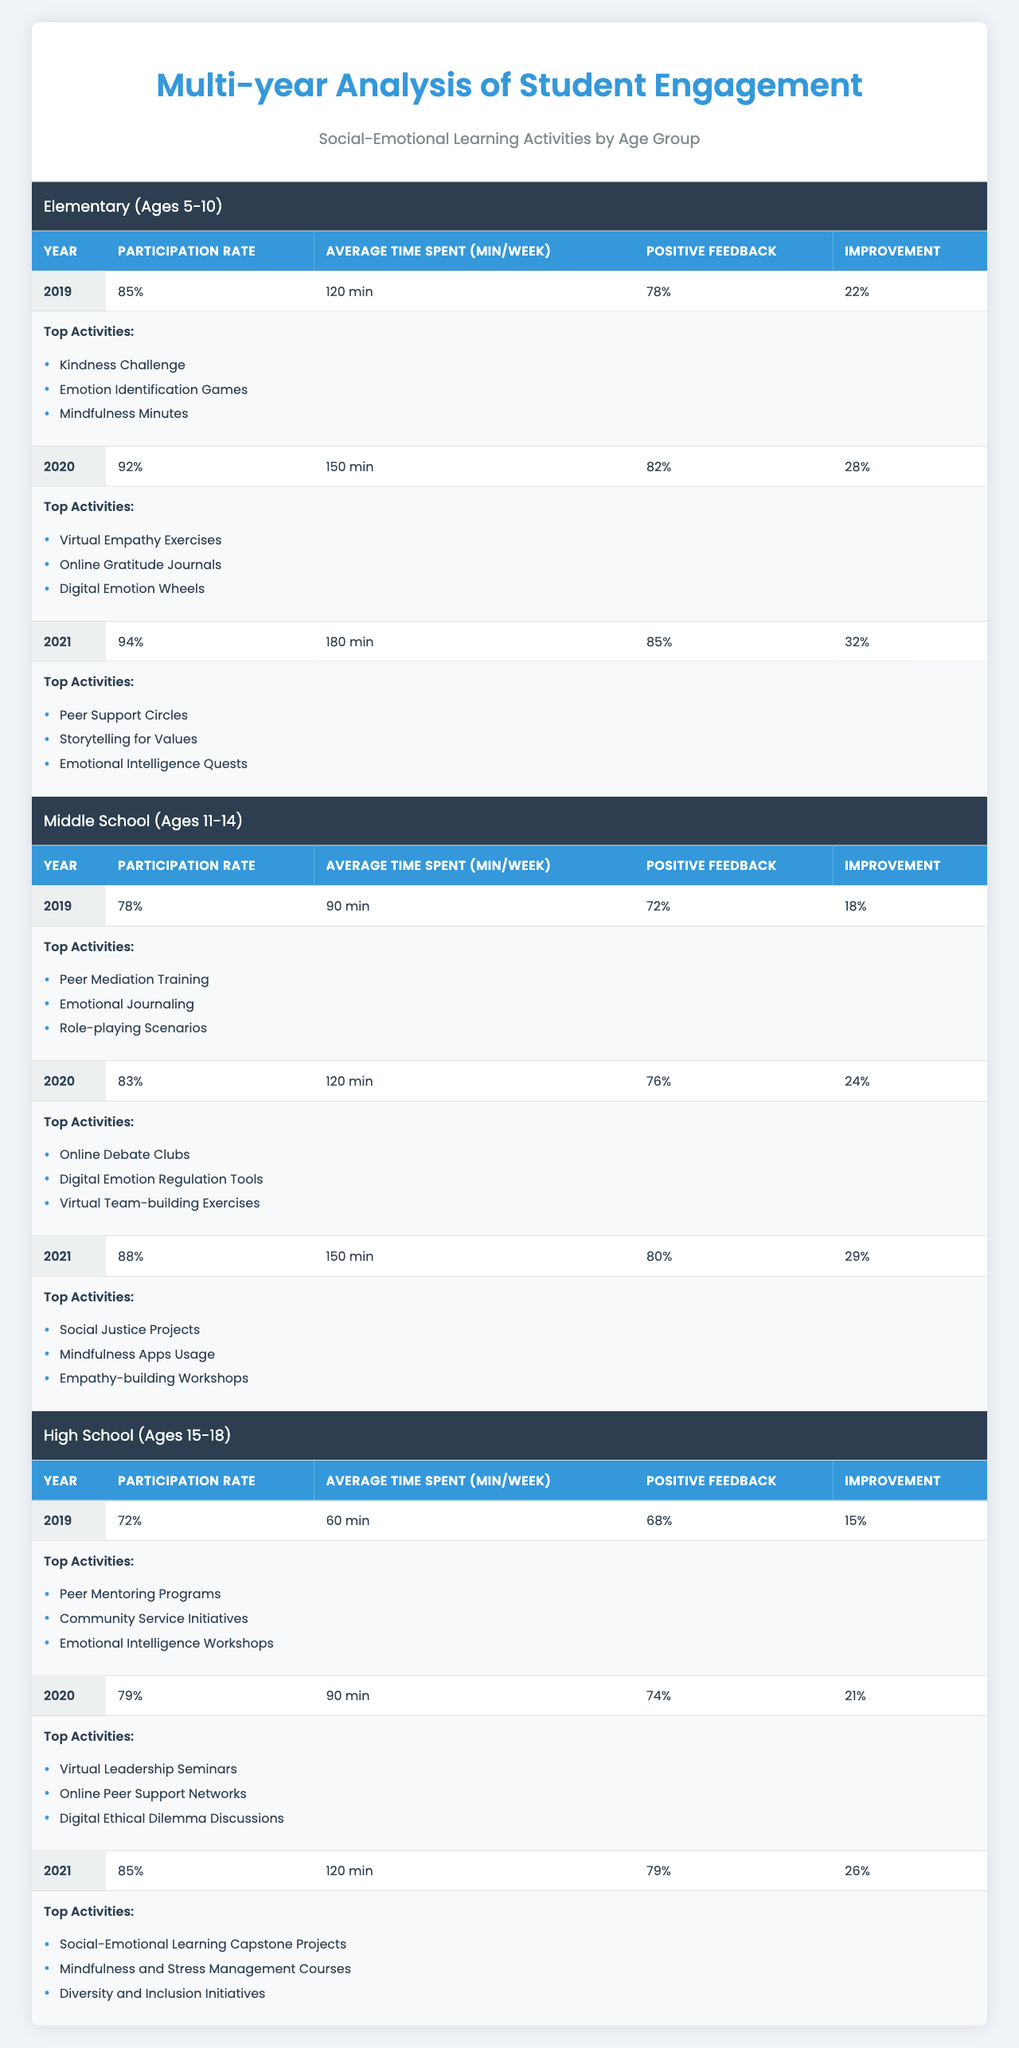What was the participation rate for Elementary students in 2021? The table shows that the participation rate for Elementary students in 2021 is 94%.
Answer: 94% Which age group had the highest average time spent on social-emotional learning activities in 2020? The table shows that the Middle School group had an average time spent of 120 minutes/week in 2020, which is higher than the other age groups.
Answer: Middle School How much did the participation rate increase for High School students from 2019 to 2021? The participation rates were 72% in 2019 and 85% in 2021. The increase is calculated as 85% - 72% = 13%.
Answer: 13% Did the Positive Feedback percentage for Middle School students improve from 2019 to 2020? In 2019, the Positive Feedback percentage was 72%, and in 2020, it was 76%, which indicates an improvement.
Answer: Yes What is the average Participation Rate for all age groups in 2021? The participation rates in 2021 are 94% (Elementary), 88% (Middle School), and 85% (High School). The average is (94 + 88 + 85) / 3 = 89%.
Answer: 89% Which age group had the highest improvement in Emotional Recognition from 2019 to 2021? The Elementary group had improvements of 22% in 2019 and 32% in 2021, leading to a total improvement of 10%. The Middle School's improvement increased from 18% to 29% (11%). The High School's improvement was from 15% to 26% (11%). Therefore, the Elementary group had the highest improvement.
Answer: Elementary List the top activities for Middle School students in 2021. According to the table, the top activities for Middle School students in 2021 include Social Justice Projects, Mindfulness Apps Usage, and Empathy-building Workshops.
Answer: Social Justice Projects, Mindfulness Apps Usage, Empathy-building Workshops What is the difference in average time spent on activities between Elementary and High School students in 2021? The average time spent for Elementary students in 2021 is 180 minutes/week, while for High School students it is 120 minutes/week. The difference is calculated as 180 - 120 = 60 minutes.
Answer: 60 minutes Which year saw the highest Positive Feedback percentage for High School students? Looking at the data, the highest Positive Feedback percentage for High School students was 79% in 2021.
Answer: 2021 Did participation rates for Middle School students show a consistent increase each year? Examining the table shows participation rates for Middle School students as 78% in 2019, 83% in 2020, and 88% in 2021, indicating a consistent increase each year.
Answer: Yes 